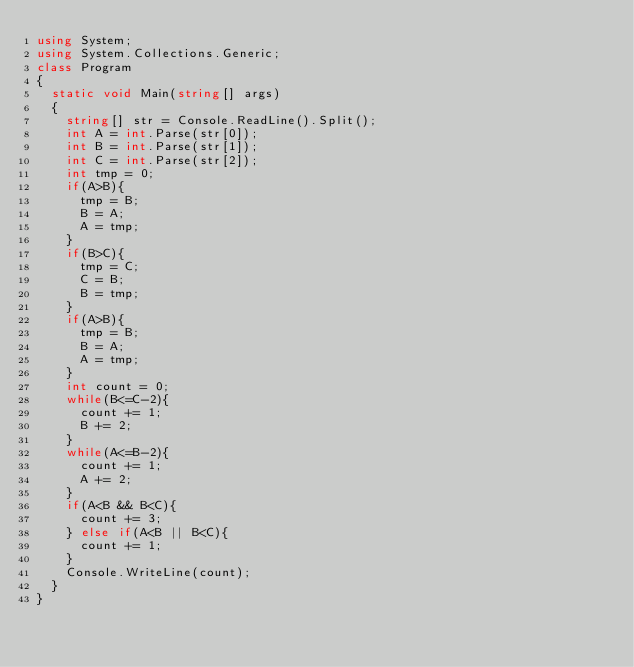<code> <loc_0><loc_0><loc_500><loc_500><_C#_>using System;
using System.Collections.Generic;
class Program
{
	static void Main(string[] args)
	{
		string[] str = Console.ReadLine().Split();
		int A = int.Parse(str[0]);
		int B = int.Parse(str[1]);
		int C = int.Parse(str[2]);
		int tmp = 0;
		if(A>B){
			tmp = B;
			B = A;
			A = tmp;
		}
		if(B>C){
			tmp = C;
			C = B;
			B = tmp;
		}
		if(A>B){
			tmp = B;
			B = A;
			A = tmp;
		}
		int count = 0;
		while(B<=C-2){
			count += 1;
			B += 2;
		}
		while(A<=B-2){
			count += 1;
			A += 2;
		}
		if(A<B && B<C){
			count += 3;
		} else if(A<B || B<C){
			count += 1;
		}
		Console.WriteLine(count);
	}
}</code> 